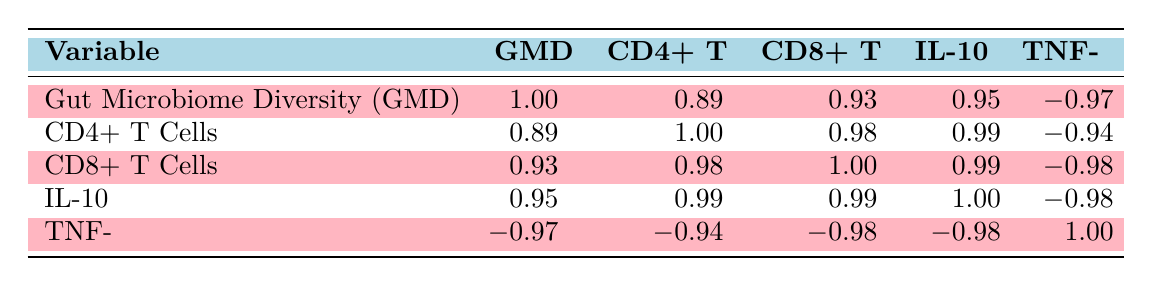What is the correlation coefficient between Gut Microbiome Diversity and CD4+ T Cells? The table shows that the correlation coefficient between Gut Microbiome Diversity (GMD) and CD4+ T Cells is 0.89.
Answer: 0.89 What is the correlation between TNF-α and Gut Microbiome Diversity? The correlation value for TNF-α and Gut Microbiome Diversity is -0.97, indicating a strong negative correlation.
Answer: -0.97 Do higher levels of Gut Microbiome Diversity correlate with increased levels of IL-10? Yes, the table indicates a correlation coefficient of 0.95 between Gut Microbiome Diversity and IL-10, suggesting that higher gut microbiome diversity is associated with increased IL-10 levels.
Answer: Yes What is the highest correlation coefficient observed in the table? Upon reviewing all correlation coefficients, the highest value is 1.00, which occurs for any variable with itself, as shown in the diagonal of the table.
Answer: 1.00 What is the relationship between CD8+ T Cells and IL-10 based on the table? The correlation between CD8+ T Cells and IL-10 is 0.99, indicating a very strong positive relationship; as one increases, the other tends to increase as well.
Answer: 0.99 Calculate the average correlation coefficient from the columns related to immune markers (CD4+ T Cells, CD8+ T Cells, IL-10, TNF-α) The correlation coefficients for immune markers are 0.89, 0.93, 0.95, and -0.97. The average is calculated as (0.89 + 0.93 + 0.95 - 0.97) / 4 = 0.45 / 4 = 0.1125.
Answer: 0.1125 Is there a positive correlation between CD4+ T Cells and CD8+ T Cells? Yes, the correlation coefficient between CD4+ T Cells and CD8+ T Cells is 0.98, indicating a strong positive correlation.
Answer: Yes What is the correlation between IL-10 and CD4+ T Cells? The correlation coefficient between IL-10 and CD4+ T Cells is 0.99, indicating a strong positive relationship.
Answer: 0.99 How does Gut Microbiome Diversity affect TNF-α levels? The table indicates a negative correlation of -0.97 between Gut Microbiome Diversity and TNF-α, suggesting that higher gut microbiome diversity is associated with lower TNF-α levels.
Answer: -0.97 